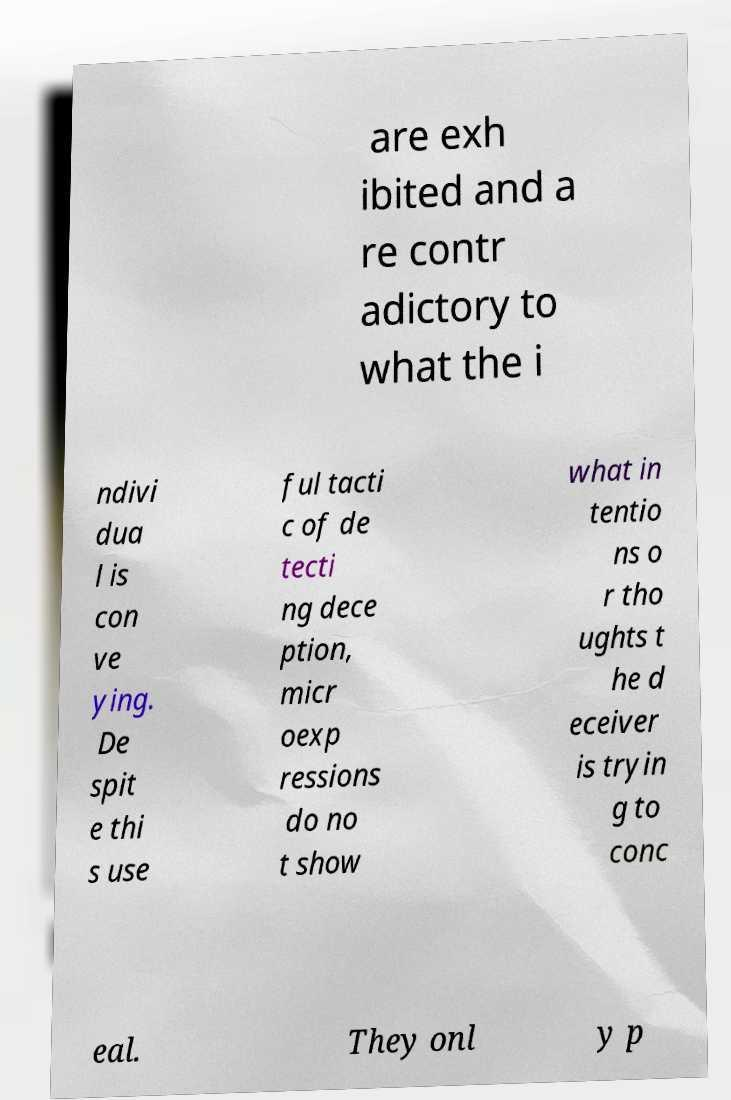For documentation purposes, I need the text within this image transcribed. Could you provide that? are exh ibited and a re contr adictory to what the i ndivi dua l is con ve ying. De spit e thi s use ful tacti c of de tecti ng dece ption, micr oexp ressions do no t show what in tentio ns o r tho ughts t he d eceiver is tryin g to conc eal. They onl y p 